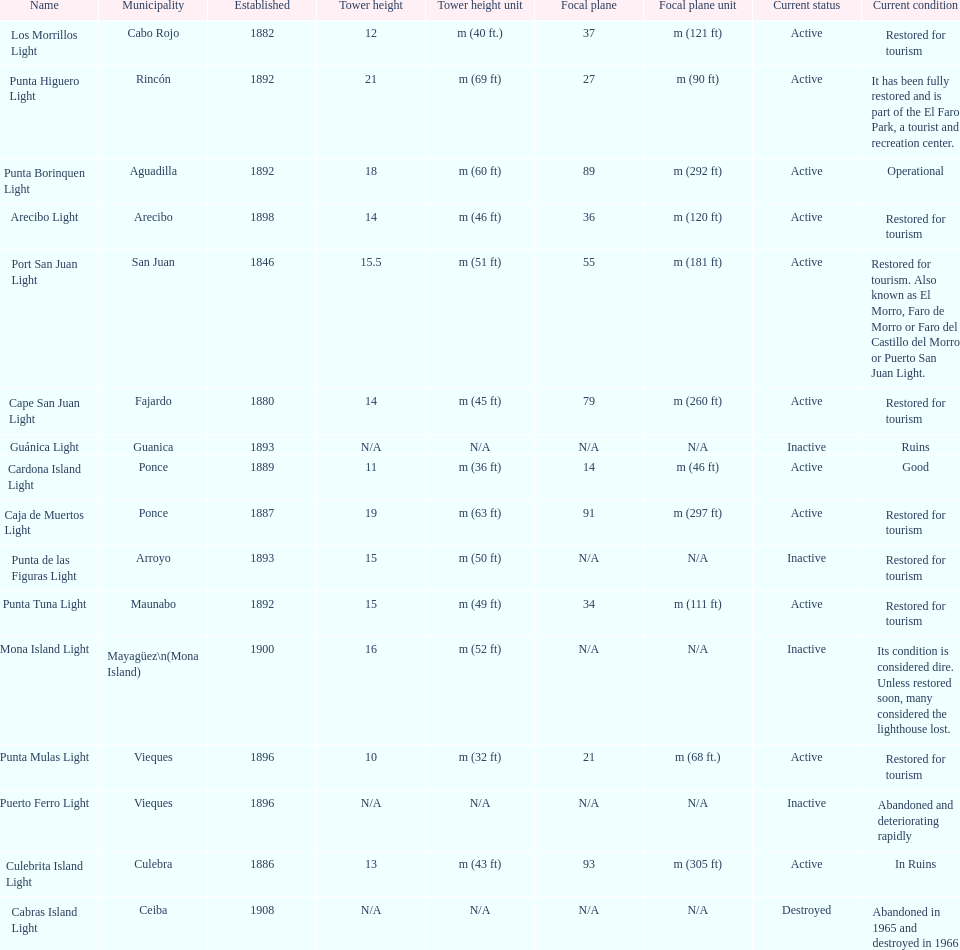Number of lighthouses that begin with the letter p 7. 